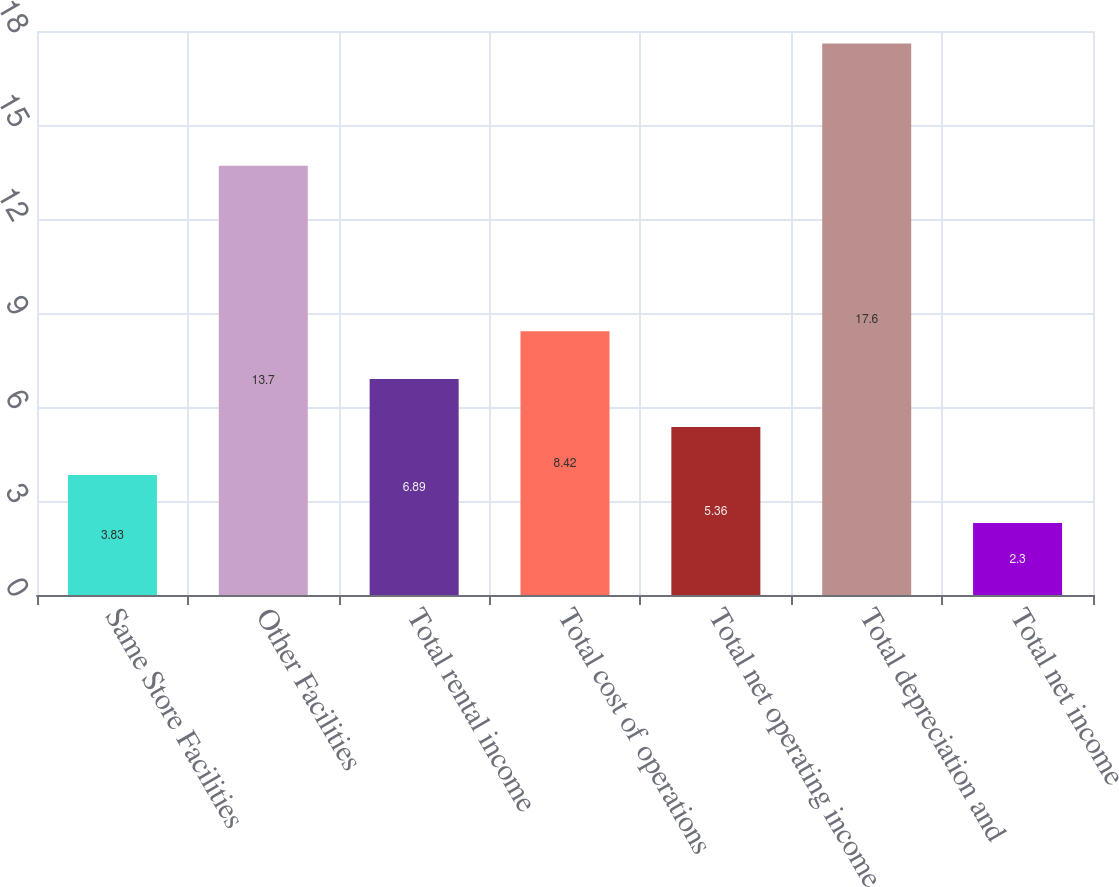Convert chart to OTSL. <chart><loc_0><loc_0><loc_500><loc_500><bar_chart><fcel>Same Store Facilities<fcel>Other Facilities<fcel>Total rental income<fcel>Total cost of operations<fcel>Total net operating income<fcel>Total depreciation and<fcel>Total net income<nl><fcel>3.83<fcel>13.7<fcel>6.89<fcel>8.42<fcel>5.36<fcel>17.6<fcel>2.3<nl></chart> 